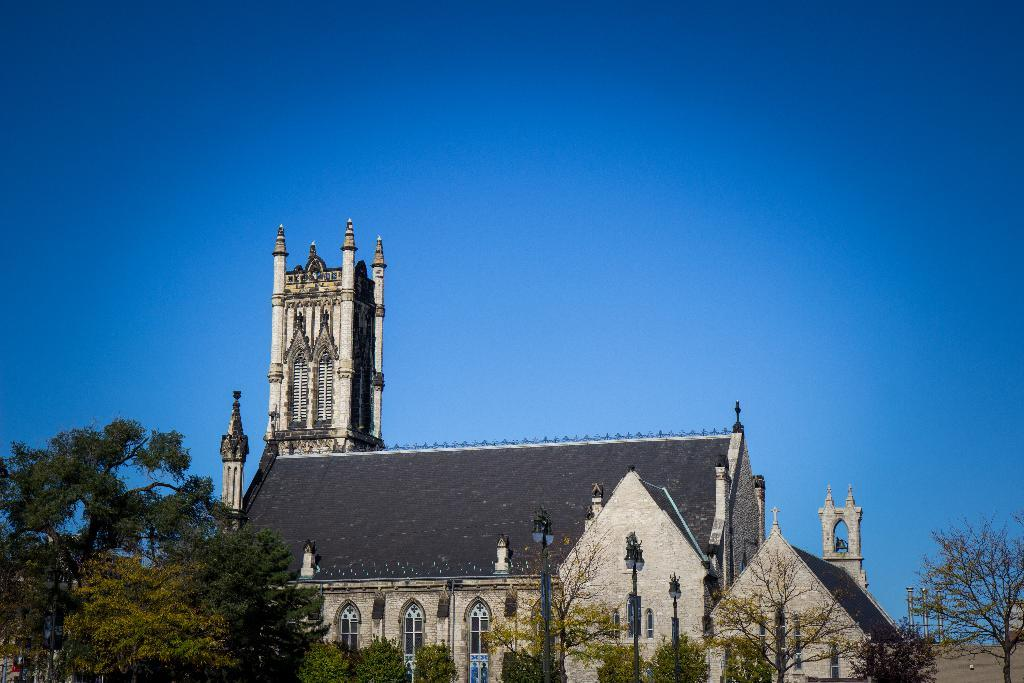What type of structure is present in the image? There is a building in the image. What specific features can be seen on the building? There are towers on the building. What other objects are visible in the image? There are trees and light poles in the image. What is visible at the top of the image? The sky is visible at the top of the image. How many pins are holding the knot together in the image? There are no pins or knots present in the image. 